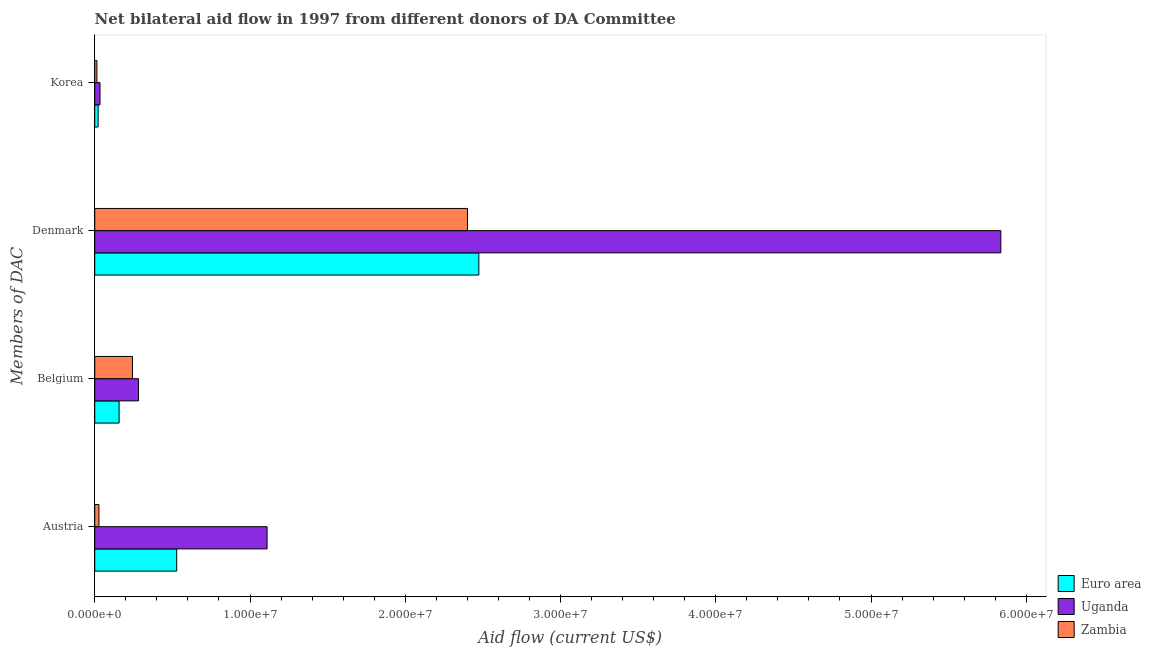How many groups of bars are there?
Your answer should be compact. 4. Are the number of bars per tick equal to the number of legend labels?
Your answer should be compact. Yes. Are the number of bars on each tick of the Y-axis equal?
Make the answer very short. Yes. How many bars are there on the 4th tick from the bottom?
Give a very brief answer. 3. What is the amount of aid given by korea in Zambia?
Your answer should be compact. 1.40e+05. Across all countries, what is the maximum amount of aid given by belgium?
Provide a succinct answer. 2.82e+06. Across all countries, what is the minimum amount of aid given by belgium?
Your answer should be compact. 1.57e+06. In which country was the amount of aid given by denmark maximum?
Provide a short and direct response. Uganda. In which country was the amount of aid given by belgium minimum?
Your answer should be very brief. Euro area. What is the total amount of aid given by denmark in the graph?
Give a very brief answer. 1.07e+08. What is the difference between the amount of aid given by austria in Euro area and that in Uganda?
Provide a short and direct response. -5.82e+06. What is the difference between the amount of aid given by austria in Uganda and the amount of aid given by korea in Euro area?
Give a very brief answer. 1.09e+07. What is the average amount of aid given by denmark per country?
Ensure brevity in your answer.  3.57e+07. What is the difference between the amount of aid given by korea and amount of aid given by belgium in Uganda?
Give a very brief answer. -2.48e+06. In how many countries, is the amount of aid given by korea greater than 56000000 US$?
Your answer should be very brief. 0. What is the ratio of the amount of aid given by belgium in Zambia to that in Uganda?
Offer a terse response. 0.86. Is the amount of aid given by korea in Euro area less than that in Zambia?
Keep it short and to the point. No. Is the difference between the amount of aid given by korea in Uganda and Zambia greater than the difference between the amount of aid given by belgium in Uganda and Zambia?
Keep it short and to the point. No. What is the difference between the highest and the second highest amount of aid given by austria?
Your answer should be compact. 5.82e+06. What is the difference between the highest and the lowest amount of aid given by austria?
Give a very brief answer. 1.08e+07. In how many countries, is the amount of aid given by belgium greater than the average amount of aid given by belgium taken over all countries?
Ensure brevity in your answer.  2. Is it the case that in every country, the sum of the amount of aid given by belgium and amount of aid given by denmark is greater than the sum of amount of aid given by austria and amount of aid given by korea?
Your answer should be very brief. Yes. What does the 1st bar from the top in Austria represents?
Make the answer very short. Zambia. What does the 3rd bar from the bottom in Austria represents?
Offer a very short reply. Zambia. Are all the bars in the graph horizontal?
Provide a short and direct response. Yes. How many countries are there in the graph?
Your answer should be very brief. 3. What is the difference between two consecutive major ticks on the X-axis?
Your answer should be compact. 1.00e+07. Are the values on the major ticks of X-axis written in scientific E-notation?
Provide a short and direct response. Yes. Does the graph contain any zero values?
Keep it short and to the point. No. How are the legend labels stacked?
Provide a short and direct response. Vertical. What is the title of the graph?
Ensure brevity in your answer.  Net bilateral aid flow in 1997 from different donors of DA Committee. Does "Dominican Republic" appear as one of the legend labels in the graph?
Provide a succinct answer. No. What is the label or title of the Y-axis?
Make the answer very short. Members of DAC. What is the Aid flow (current US$) of Euro area in Austria?
Provide a succinct answer. 5.28e+06. What is the Aid flow (current US$) of Uganda in Austria?
Your response must be concise. 1.11e+07. What is the Aid flow (current US$) in Euro area in Belgium?
Your answer should be compact. 1.57e+06. What is the Aid flow (current US$) of Uganda in Belgium?
Offer a terse response. 2.82e+06. What is the Aid flow (current US$) in Zambia in Belgium?
Provide a succinct answer. 2.43e+06. What is the Aid flow (current US$) of Euro area in Denmark?
Offer a very short reply. 2.47e+07. What is the Aid flow (current US$) in Uganda in Denmark?
Offer a terse response. 5.84e+07. What is the Aid flow (current US$) of Zambia in Denmark?
Offer a terse response. 2.40e+07. What is the Aid flow (current US$) in Euro area in Korea?
Provide a succinct answer. 2.20e+05. What is the Aid flow (current US$) in Uganda in Korea?
Keep it short and to the point. 3.40e+05. What is the Aid flow (current US$) of Zambia in Korea?
Offer a very short reply. 1.40e+05. Across all Members of DAC, what is the maximum Aid flow (current US$) of Euro area?
Your answer should be compact. 2.47e+07. Across all Members of DAC, what is the maximum Aid flow (current US$) in Uganda?
Give a very brief answer. 5.84e+07. Across all Members of DAC, what is the maximum Aid flow (current US$) of Zambia?
Provide a short and direct response. 2.40e+07. Across all Members of DAC, what is the minimum Aid flow (current US$) in Zambia?
Provide a succinct answer. 1.40e+05. What is the total Aid flow (current US$) in Euro area in the graph?
Ensure brevity in your answer.  3.18e+07. What is the total Aid flow (current US$) of Uganda in the graph?
Offer a very short reply. 7.26e+07. What is the total Aid flow (current US$) in Zambia in the graph?
Your answer should be very brief. 2.68e+07. What is the difference between the Aid flow (current US$) of Euro area in Austria and that in Belgium?
Keep it short and to the point. 3.71e+06. What is the difference between the Aid flow (current US$) of Uganda in Austria and that in Belgium?
Your answer should be very brief. 8.28e+06. What is the difference between the Aid flow (current US$) of Zambia in Austria and that in Belgium?
Ensure brevity in your answer.  -2.16e+06. What is the difference between the Aid flow (current US$) in Euro area in Austria and that in Denmark?
Your answer should be very brief. -1.95e+07. What is the difference between the Aid flow (current US$) in Uganda in Austria and that in Denmark?
Your answer should be very brief. -4.73e+07. What is the difference between the Aid flow (current US$) of Zambia in Austria and that in Denmark?
Ensure brevity in your answer.  -2.37e+07. What is the difference between the Aid flow (current US$) of Euro area in Austria and that in Korea?
Your response must be concise. 5.06e+06. What is the difference between the Aid flow (current US$) in Uganda in Austria and that in Korea?
Provide a short and direct response. 1.08e+07. What is the difference between the Aid flow (current US$) in Euro area in Belgium and that in Denmark?
Your answer should be very brief. -2.32e+07. What is the difference between the Aid flow (current US$) of Uganda in Belgium and that in Denmark?
Provide a succinct answer. -5.55e+07. What is the difference between the Aid flow (current US$) in Zambia in Belgium and that in Denmark?
Your answer should be compact. -2.16e+07. What is the difference between the Aid flow (current US$) of Euro area in Belgium and that in Korea?
Ensure brevity in your answer.  1.35e+06. What is the difference between the Aid flow (current US$) of Uganda in Belgium and that in Korea?
Offer a very short reply. 2.48e+06. What is the difference between the Aid flow (current US$) in Zambia in Belgium and that in Korea?
Provide a succinct answer. 2.29e+06. What is the difference between the Aid flow (current US$) in Euro area in Denmark and that in Korea?
Give a very brief answer. 2.45e+07. What is the difference between the Aid flow (current US$) of Uganda in Denmark and that in Korea?
Ensure brevity in your answer.  5.80e+07. What is the difference between the Aid flow (current US$) in Zambia in Denmark and that in Korea?
Make the answer very short. 2.39e+07. What is the difference between the Aid flow (current US$) in Euro area in Austria and the Aid flow (current US$) in Uganda in Belgium?
Make the answer very short. 2.46e+06. What is the difference between the Aid flow (current US$) in Euro area in Austria and the Aid flow (current US$) in Zambia in Belgium?
Offer a very short reply. 2.85e+06. What is the difference between the Aid flow (current US$) in Uganda in Austria and the Aid flow (current US$) in Zambia in Belgium?
Provide a short and direct response. 8.67e+06. What is the difference between the Aid flow (current US$) in Euro area in Austria and the Aid flow (current US$) in Uganda in Denmark?
Offer a terse response. -5.31e+07. What is the difference between the Aid flow (current US$) in Euro area in Austria and the Aid flow (current US$) in Zambia in Denmark?
Ensure brevity in your answer.  -1.87e+07. What is the difference between the Aid flow (current US$) in Uganda in Austria and the Aid flow (current US$) in Zambia in Denmark?
Provide a short and direct response. -1.29e+07. What is the difference between the Aid flow (current US$) of Euro area in Austria and the Aid flow (current US$) of Uganda in Korea?
Your answer should be very brief. 4.94e+06. What is the difference between the Aid flow (current US$) of Euro area in Austria and the Aid flow (current US$) of Zambia in Korea?
Give a very brief answer. 5.14e+06. What is the difference between the Aid flow (current US$) in Uganda in Austria and the Aid flow (current US$) in Zambia in Korea?
Provide a succinct answer. 1.10e+07. What is the difference between the Aid flow (current US$) of Euro area in Belgium and the Aid flow (current US$) of Uganda in Denmark?
Keep it short and to the point. -5.68e+07. What is the difference between the Aid flow (current US$) in Euro area in Belgium and the Aid flow (current US$) in Zambia in Denmark?
Give a very brief answer. -2.24e+07. What is the difference between the Aid flow (current US$) in Uganda in Belgium and the Aid flow (current US$) in Zambia in Denmark?
Provide a short and direct response. -2.12e+07. What is the difference between the Aid flow (current US$) in Euro area in Belgium and the Aid flow (current US$) in Uganda in Korea?
Offer a terse response. 1.23e+06. What is the difference between the Aid flow (current US$) of Euro area in Belgium and the Aid flow (current US$) of Zambia in Korea?
Your answer should be compact. 1.43e+06. What is the difference between the Aid flow (current US$) in Uganda in Belgium and the Aid flow (current US$) in Zambia in Korea?
Your answer should be very brief. 2.68e+06. What is the difference between the Aid flow (current US$) in Euro area in Denmark and the Aid flow (current US$) in Uganda in Korea?
Make the answer very short. 2.44e+07. What is the difference between the Aid flow (current US$) in Euro area in Denmark and the Aid flow (current US$) in Zambia in Korea?
Provide a succinct answer. 2.46e+07. What is the difference between the Aid flow (current US$) of Uganda in Denmark and the Aid flow (current US$) of Zambia in Korea?
Provide a succinct answer. 5.82e+07. What is the average Aid flow (current US$) in Euro area per Members of DAC?
Offer a terse response. 7.95e+06. What is the average Aid flow (current US$) of Uganda per Members of DAC?
Offer a very short reply. 1.82e+07. What is the average Aid flow (current US$) in Zambia per Members of DAC?
Your response must be concise. 6.71e+06. What is the difference between the Aid flow (current US$) in Euro area and Aid flow (current US$) in Uganda in Austria?
Provide a succinct answer. -5.82e+06. What is the difference between the Aid flow (current US$) of Euro area and Aid flow (current US$) of Zambia in Austria?
Offer a terse response. 5.01e+06. What is the difference between the Aid flow (current US$) of Uganda and Aid flow (current US$) of Zambia in Austria?
Offer a very short reply. 1.08e+07. What is the difference between the Aid flow (current US$) of Euro area and Aid flow (current US$) of Uganda in Belgium?
Offer a terse response. -1.25e+06. What is the difference between the Aid flow (current US$) in Euro area and Aid flow (current US$) in Zambia in Belgium?
Provide a short and direct response. -8.60e+05. What is the difference between the Aid flow (current US$) in Euro area and Aid flow (current US$) in Uganda in Denmark?
Ensure brevity in your answer.  -3.36e+07. What is the difference between the Aid flow (current US$) of Euro area and Aid flow (current US$) of Zambia in Denmark?
Your response must be concise. 7.30e+05. What is the difference between the Aid flow (current US$) of Uganda and Aid flow (current US$) of Zambia in Denmark?
Provide a short and direct response. 3.44e+07. What is the difference between the Aid flow (current US$) in Euro area and Aid flow (current US$) in Uganda in Korea?
Keep it short and to the point. -1.20e+05. What is the difference between the Aid flow (current US$) of Uganda and Aid flow (current US$) of Zambia in Korea?
Keep it short and to the point. 2.00e+05. What is the ratio of the Aid flow (current US$) of Euro area in Austria to that in Belgium?
Your answer should be compact. 3.36. What is the ratio of the Aid flow (current US$) of Uganda in Austria to that in Belgium?
Provide a short and direct response. 3.94. What is the ratio of the Aid flow (current US$) in Euro area in Austria to that in Denmark?
Offer a very short reply. 0.21. What is the ratio of the Aid flow (current US$) in Uganda in Austria to that in Denmark?
Offer a very short reply. 0.19. What is the ratio of the Aid flow (current US$) in Zambia in Austria to that in Denmark?
Give a very brief answer. 0.01. What is the ratio of the Aid flow (current US$) in Euro area in Austria to that in Korea?
Offer a terse response. 24. What is the ratio of the Aid flow (current US$) in Uganda in Austria to that in Korea?
Offer a very short reply. 32.65. What is the ratio of the Aid flow (current US$) in Zambia in Austria to that in Korea?
Provide a succinct answer. 1.93. What is the ratio of the Aid flow (current US$) of Euro area in Belgium to that in Denmark?
Your answer should be very brief. 0.06. What is the ratio of the Aid flow (current US$) in Uganda in Belgium to that in Denmark?
Your response must be concise. 0.05. What is the ratio of the Aid flow (current US$) of Zambia in Belgium to that in Denmark?
Offer a terse response. 0.1. What is the ratio of the Aid flow (current US$) of Euro area in Belgium to that in Korea?
Your response must be concise. 7.14. What is the ratio of the Aid flow (current US$) of Uganda in Belgium to that in Korea?
Your response must be concise. 8.29. What is the ratio of the Aid flow (current US$) in Zambia in Belgium to that in Korea?
Offer a terse response. 17.36. What is the ratio of the Aid flow (current US$) of Euro area in Denmark to that in Korea?
Offer a terse response. 112.45. What is the ratio of the Aid flow (current US$) of Uganda in Denmark to that in Korea?
Your response must be concise. 171.65. What is the ratio of the Aid flow (current US$) in Zambia in Denmark to that in Korea?
Provide a succinct answer. 171.5. What is the difference between the highest and the second highest Aid flow (current US$) in Euro area?
Make the answer very short. 1.95e+07. What is the difference between the highest and the second highest Aid flow (current US$) in Uganda?
Give a very brief answer. 4.73e+07. What is the difference between the highest and the second highest Aid flow (current US$) in Zambia?
Provide a short and direct response. 2.16e+07. What is the difference between the highest and the lowest Aid flow (current US$) in Euro area?
Keep it short and to the point. 2.45e+07. What is the difference between the highest and the lowest Aid flow (current US$) in Uganda?
Your response must be concise. 5.80e+07. What is the difference between the highest and the lowest Aid flow (current US$) of Zambia?
Keep it short and to the point. 2.39e+07. 